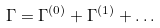<formula> <loc_0><loc_0><loc_500><loc_500>\Gamma = \Gamma ^ { ( 0 ) } + \Gamma ^ { ( 1 ) } + \dots</formula> 